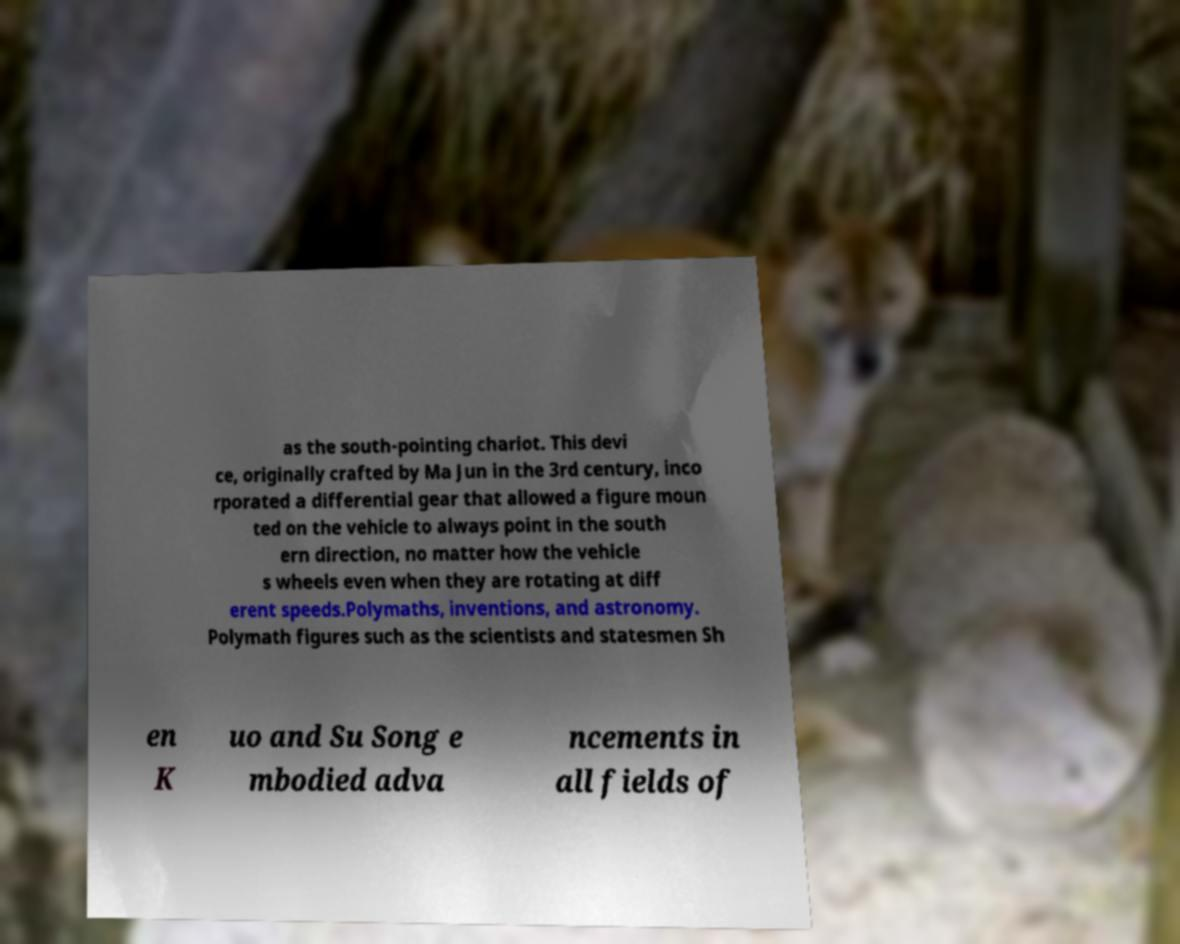Can you accurately transcribe the text from the provided image for me? as the south-pointing chariot. This devi ce, originally crafted by Ma Jun in the 3rd century, inco rporated a differential gear that allowed a figure moun ted on the vehicle to always point in the south ern direction, no matter how the vehicle s wheels even when they are rotating at diff erent speeds.Polymaths, inventions, and astronomy. Polymath figures such as the scientists and statesmen Sh en K uo and Su Song e mbodied adva ncements in all fields of 